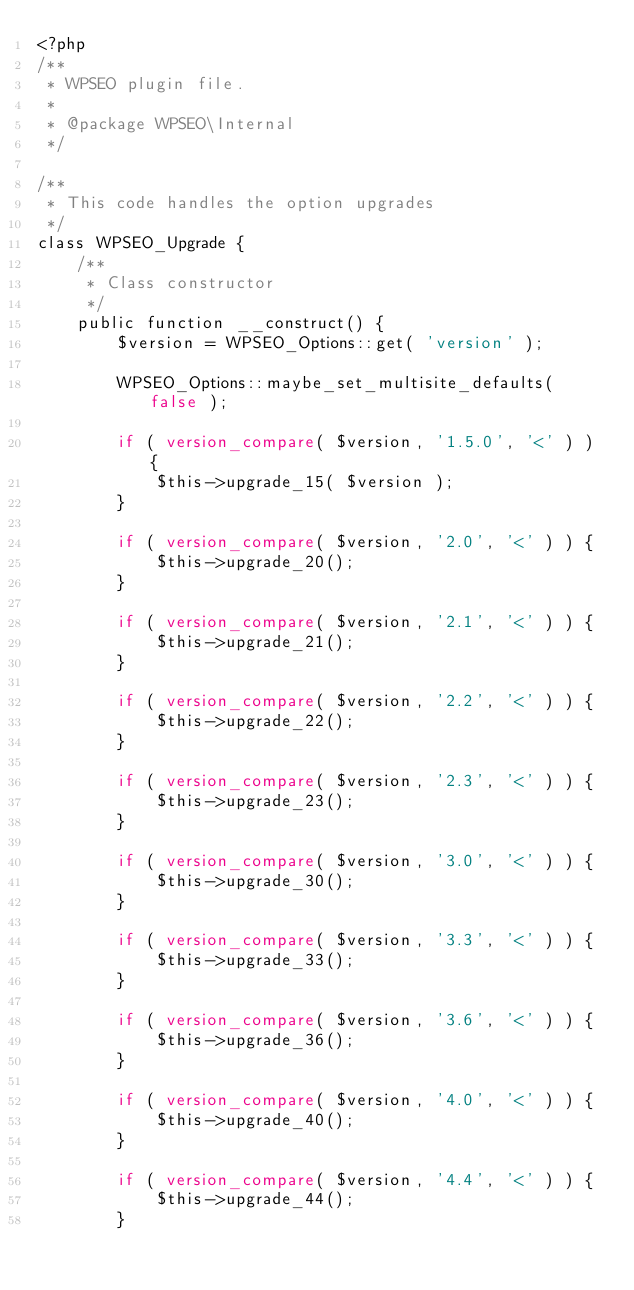<code> <loc_0><loc_0><loc_500><loc_500><_PHP_><?php
/**
 * WPSEO plugin file.
 *
 * @package WPSEO\Internal
 */

/**
 * This code handles the option upgrades
 */
class WPSEO_Upgrade {
	/**
	 * Class constructor
	 */
	public function __construct() {
		$version = WPSEO_Options::get( 'version' );

		WPSEO_Options::maybe_set_multisite_defaults( false );

		if ( version_compare( $version, '1.5.0', '<' ) ) {
			$this->upgrade_15( $version );
		}

		if ( version_compare( $version, '2.0', '<' ) ) {
			$this->upgrade_20();
		}

		if ( version_compare( $version, '2.1', '<' ) ) {
			$this->upgrade_21();
		}

		if ( version_compare( $version, '2.2', '<' ) ) {
			$this->upgrade_22();
		}

		if ( version_compare( $version, '2.3', '<' ) ) {
			$this->upgrade_23();
		}

		if ( version_compare( $version, '3.0', '<' ) ) {
			$this->upgrade_30();
		}

		if ( version_compare( $version, '3.3', '<' ) ) {
			$this->upgrade_33();
		}

		if ( version_compare( $version, '3.6', '<' ) ) {
			$this->upgrade_36();
		}

		if ( version_compare( $version, '4.0', '<' ) ) {
			$this->upgrade_40();
		}

		if ( version_compare( $version, '4.4', '<' ) ) {
			$this->upgrade_44();
		}
</code> 